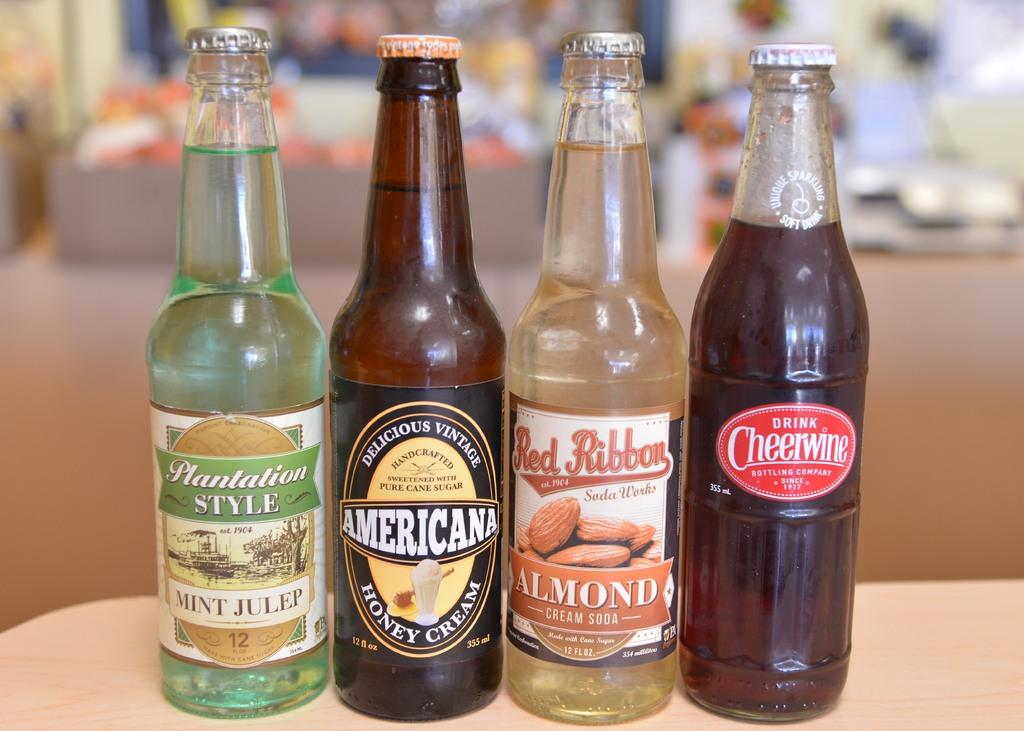<image>
Present a compact description of the photo's key features. four beer bottles, with one of them being americana honey cream 